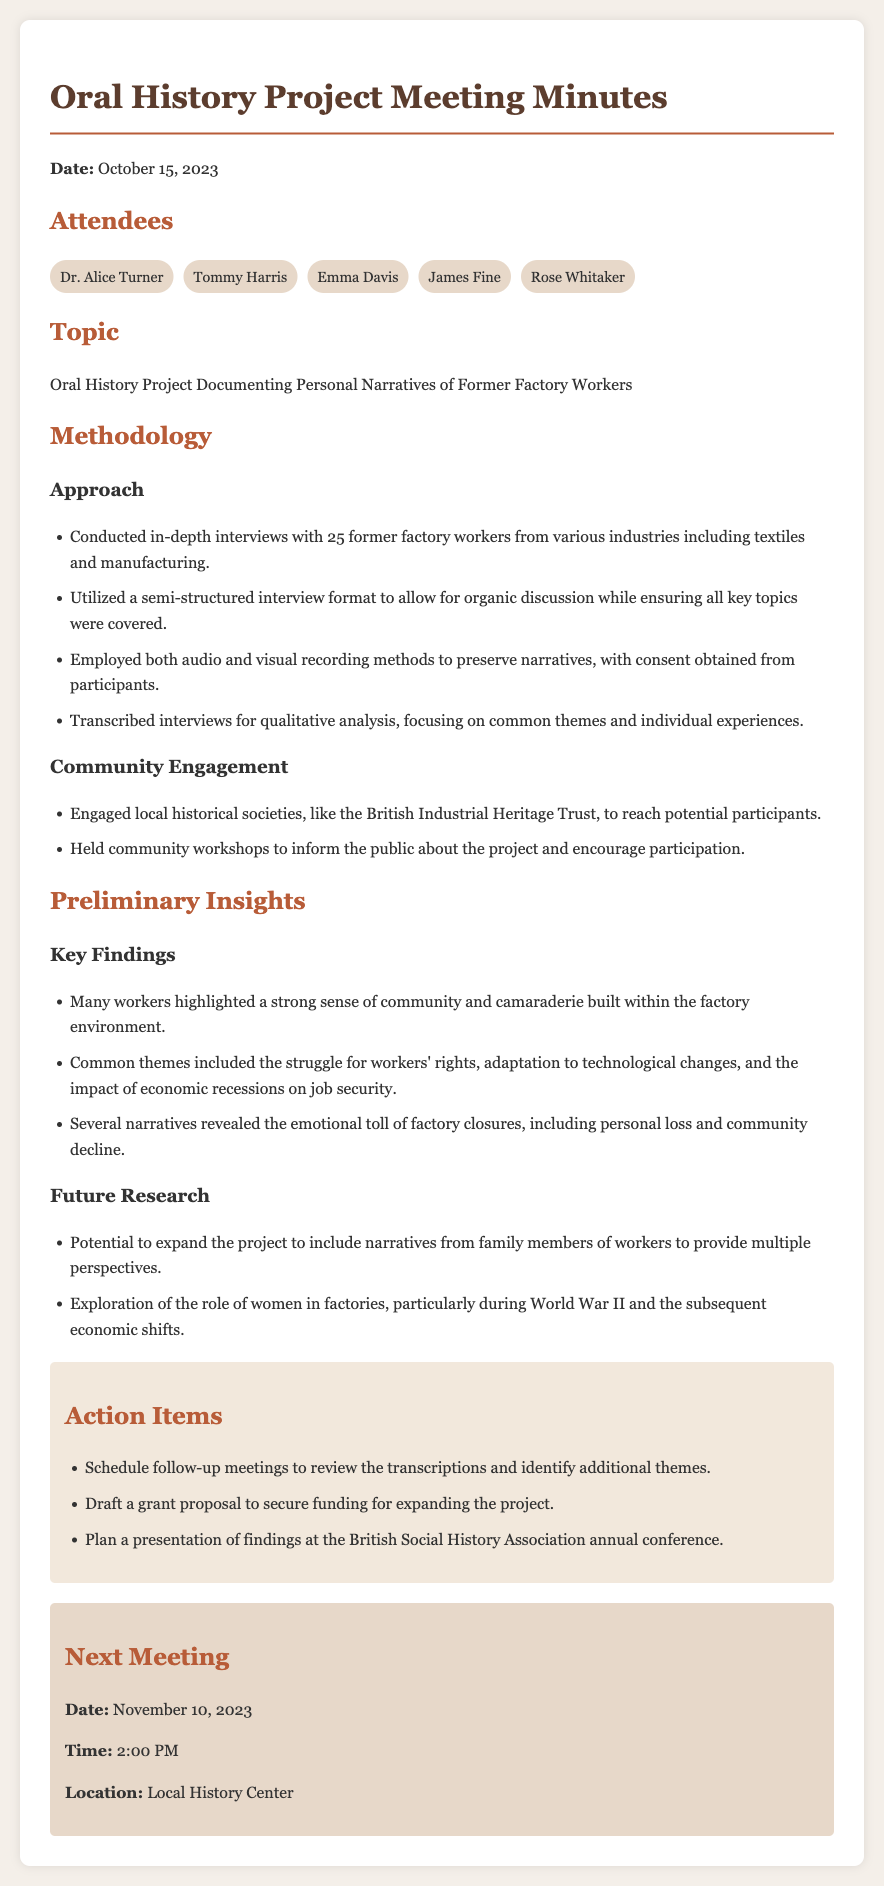What is the date of the meeting? The date of the meeting is clearly stated in the document, which is October 15, 2023.
Answer: October 15, 2023 How many former factory workers were interviewed? The document specifies that 25 former factory workers were interviewed for the project.
Answer: 25 Which local historical society was engaged for community outreach? The document mentions the British Industrial Heritage Trust as a local historical society engaged for outreach.
Answer: British Industrial Heritage Trust What is one common theme identified in the narratives? The document lists several common themes, one of which is the struggle for workers' rights.
Answer: Struggle for workers' rights When is the next meeting scheduled? The next meeting's date is provided in the document as November 10, 2023.
Answer: November 10, 2023 What methodology was employed for recording the interviews? The document states that both audio and visual recording methods were used, with consent obtained from participants.
Answer: Audio and visual recording What is a potential area for future research mentioned? The document suggests exploring the role of women in factories as a potential area for further research.
Answer: Role of women in factories What type of interview format was utilized? The document describes the interview format as semi-structured to allow organic discussion.
Answer: Semi-structured interview format 